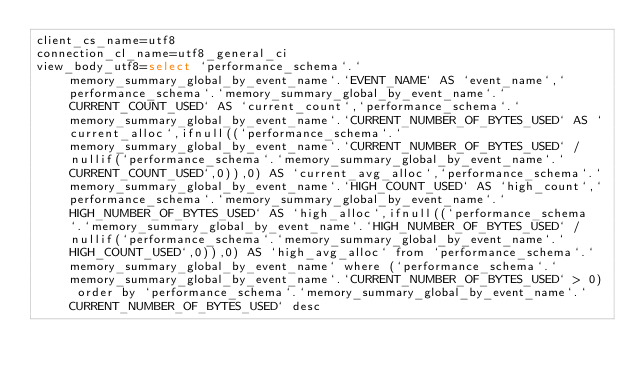<code> <loc_0><loc_0><loc_500><loc_500><_VisualBasic_>client_cs_name=utf8
connection_cl_name=utf8_general_ci
view_body_utf8=select `performance_schema`.`memory_summary_global_by_event_name`.`EVENT_NAME` AS `event_name`,`performance_schema`.`memory_summary_global_by_event_name`.`CURRENT_COUNT_USED` AS `current_count`,`performance_schema`.`memory_summary_global_by_event_name`.`CURRENT_NUMBER_OF_BYTES_USED` AS `current_alloc`,ifnull((`performance_schema`.`memory_summary_global_by_event_name`.`CURRENT_NUMBER_OF_BYTES_USED` / nullif(`performance_schema`.`memory_summary_global_by_event_name`.`CURRENT_COUNT_USED`,0)),0) AS `current_avg_alloc`,`performance_schema`.`memory_summary_global_by_event_name`.`HIGH_COUNT_USED` AS `high_count`,`performance_schema`.`memory_summary_global_by_event_name`.`HIGH_NUMBER_OF_BYTES_USED` AS `high_alloc`,ifnull((`performance_schema`.`memory_summary_global_by_event_name`.`HIGH_NUMBER_OF_BYTES_USED` / nullif(`performance_schema`.`memory_summary_global_by_event_name`.`HIGH_COUNT_USED`,0)),0) AS `high_avg_alloc` from `performance_schema`.`memory_summary_global_by_event_name` where (`performance_schema`.`memory_summary_global_by_event_name`.`CURRENT_NUMBER_OF_BYTES_USED` > 0) order by `performance_schema`.`memory_summary_global_by_event_name`.`CURRENT_NUMBER_OF_BYTES_USED` desc
</code> 